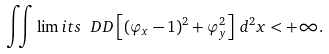Convert formula to latex. <formula><loc_0><loc_0><loc_500><loc_500>\iint \lim i t s _ { \ } D D \left [ ( \varphi _ { x } - 1 ) ^ { 2 } + \varphi _ { y } ^ { 2 } \right ] \, d ^ { 2 } x < + \infty .</formula> 